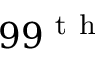<formula> <loc_0><loc_0><loc_500><loc_500>9 9 ^ { t h }</formula> 